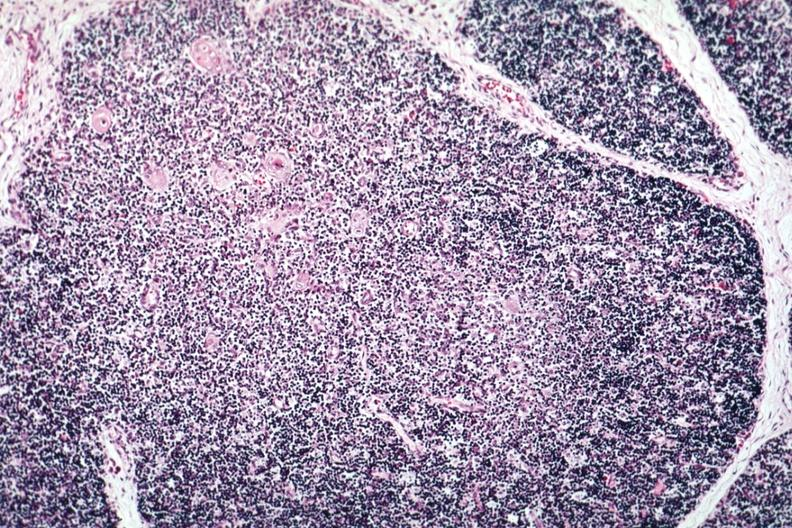s antitrypsin present?
Answer the question using a single word or phrase. No 